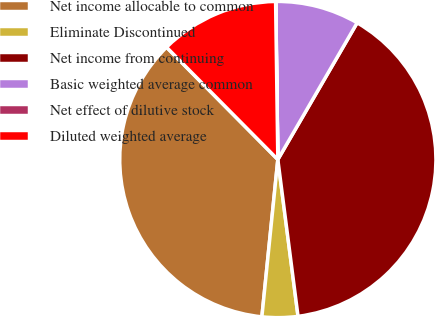<chart> <loc_0><loc_0><loc_500><loc_500><pie_chart><fcel>Net income allocable to common<fcel>Eliminate Discontinued<fcel>Net income from continuing<fcel>Basic weighted average common<fcel>Net effect of dilutive stock<fcel>Diluted weighted average<nl><fcel>35.96%<fcel>3.65%<fcel>39.59%<fcel>8.57%<fcel>0.02%<fcel>12.2%<nl></chart> 